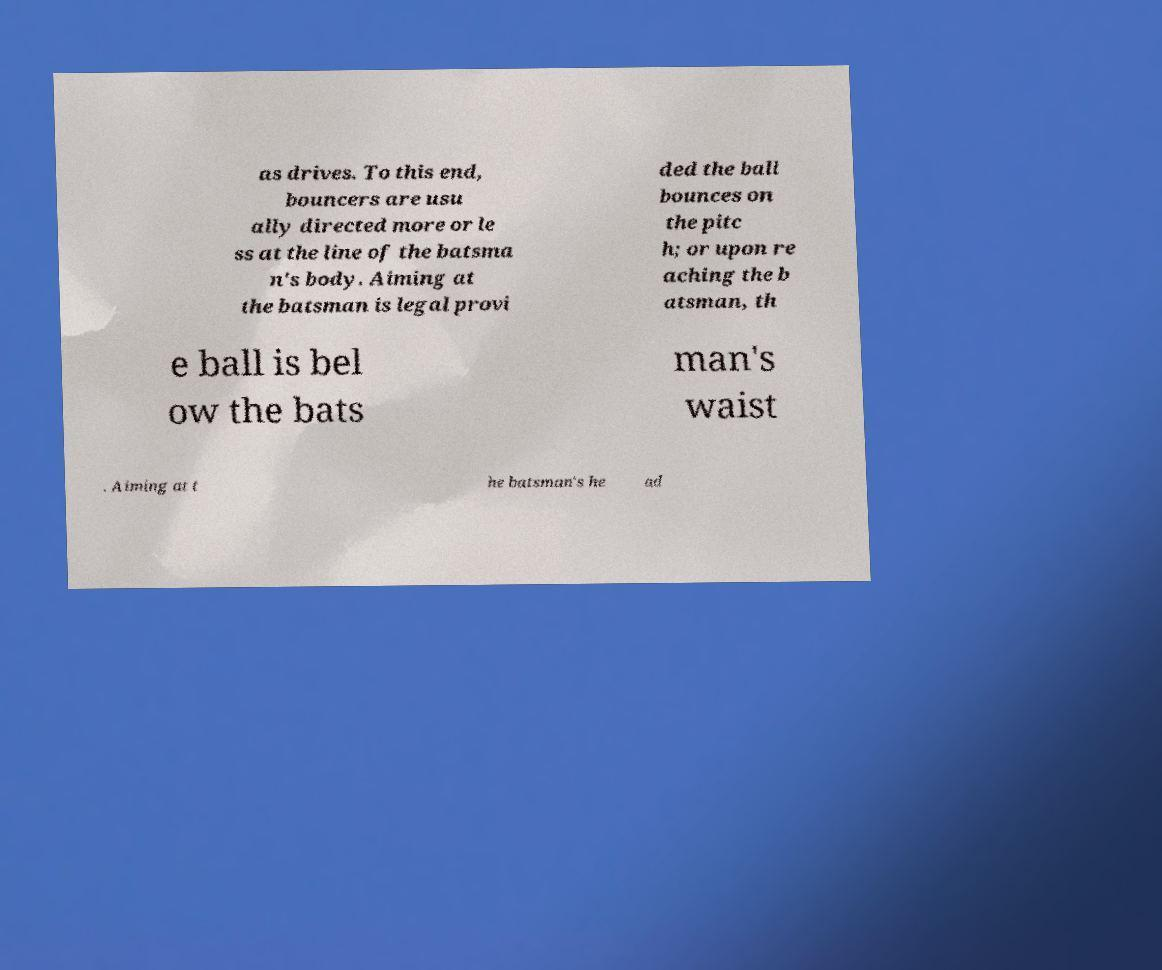I need the written content from this picture converted into text. Can you do that? as drives. To this end, bouncers are usu ally directed more or le ss at the line of the batsma n's body. Aiming at the batsman is legal provi ded the ball bounces on the pitc h; or upon re aching the b atsman, th e ball is bel ow the bats man's waist . Aiming at t he batsman's he ad 